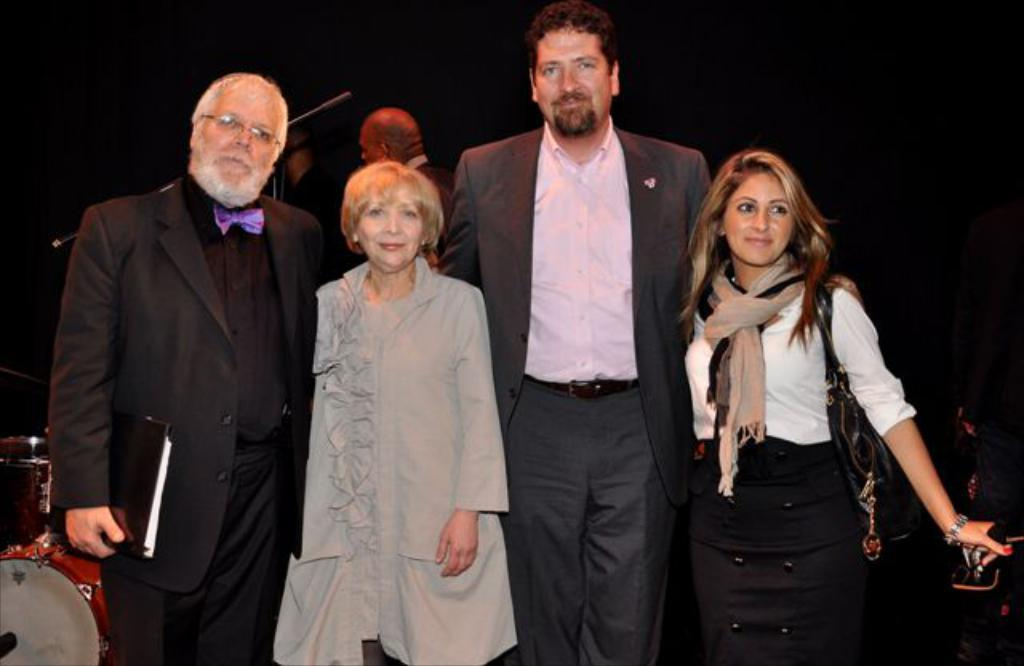What is happening in the image? There are people standing in the image. What can be seen in the background on the left side? There is a drum set on the left side in the background. Can you describe the man on the left side? There is a man on the left side holding a book, and he is wearing spectacles. Can you see a frog hopping on the hill in the image? There is no frog or hill present in the image. 